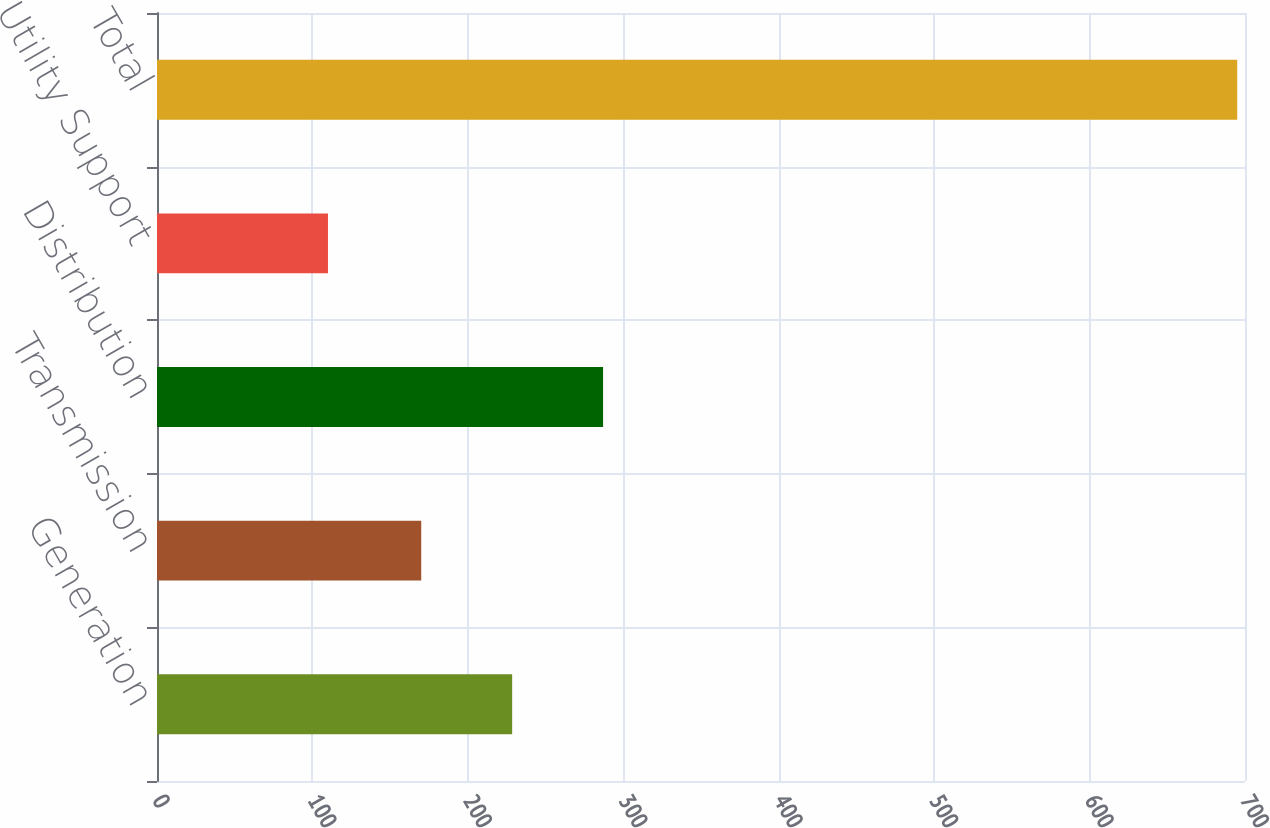Convert chart to OTSL. <chart><loc_0><loc_0><loc_500><loc_500><bar_chart><fcel>Generation<fcel>Transmission<fcel>Distribution<fcel>Utility Support<fcel>Total<nl><fcel>228.5<fcel>170<fcel>287<fcel>110<fcel>695<nl></chart> 